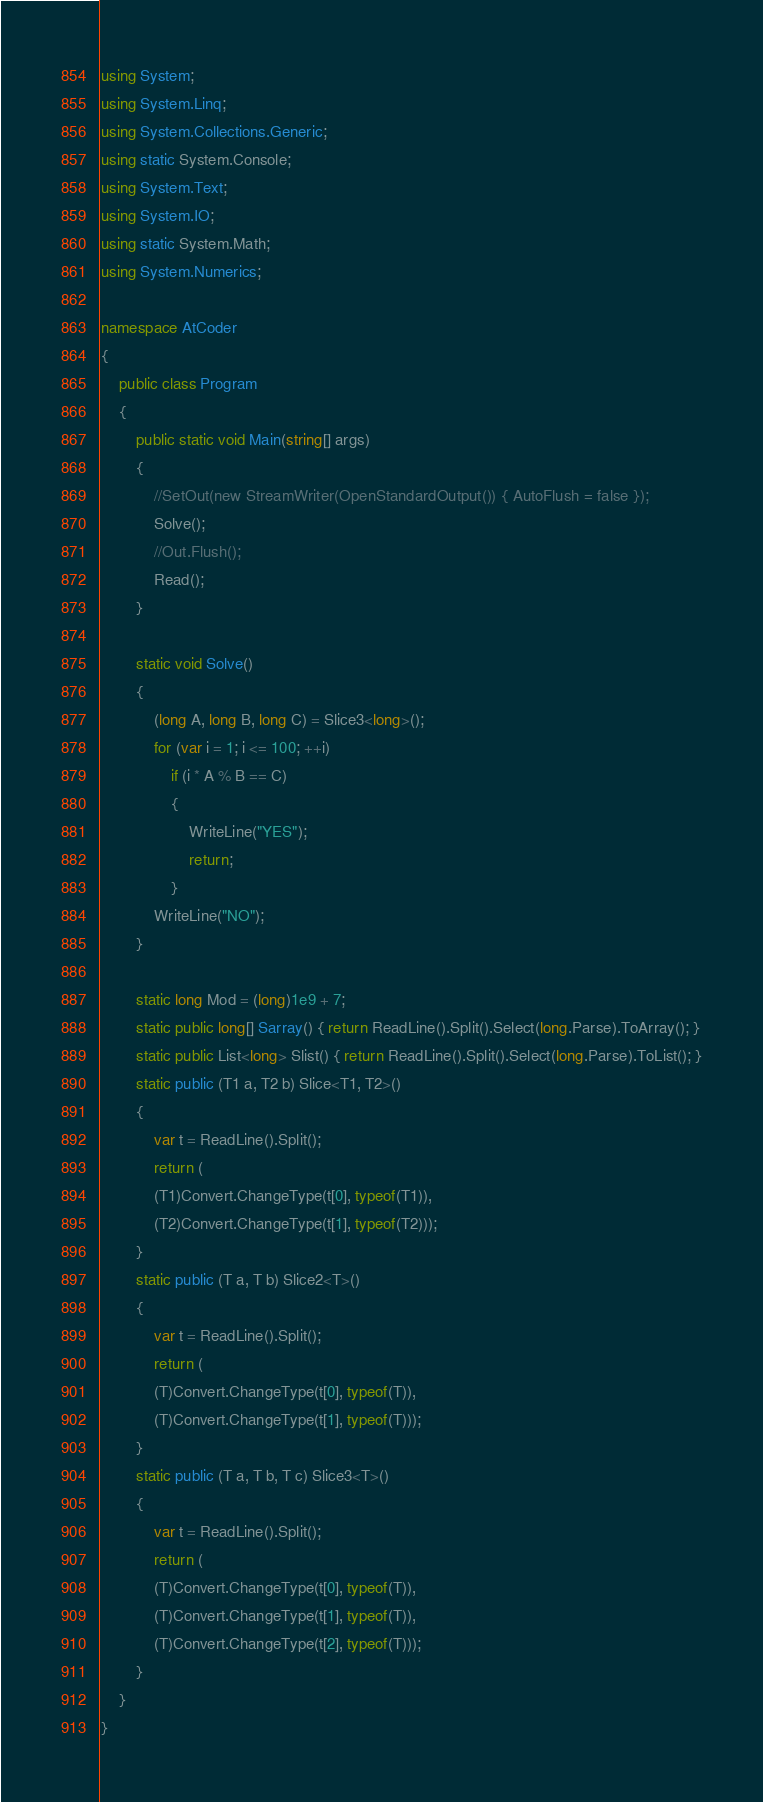<code> <loc_0><loc_0><loc_500><loc_500><_C#_>using System;
using System.Linq;
using System.Collections.Generic;
using static System.Console;
using System.Text;
using System.IO;
using static System.Math;
using System.Numerics;

namespace AtCoder
{
    public class Program
    {
        public static void Main(string[] args)
        {
            //SetOut(new StreamWriter(OpenStandardOutput()) { AutoFlush = false });
            Solve();
            //Out.Flush();
            Read();
        }

        static void Solve()
        {
            (long A, long B, long C) = Slice3<long>();
            for (var i = 1; i <= 100; ++i)
                if (i * A % B == C)
                {
                    WriteLine("YES");
                    return;
                }
            WriteLine("NO");
        }

        static long Mod = (long)1e9 + 7;
        static public long[] Sarray() { return ReadLine().Split().Select(long.Parse).ToArray(); }
        static public List<long> Slist() { return ReadLine().Split().Select(long.Parse).ToList(); }
        static public (T1 a, T2 b) Slice<T1, T2>()
        {
            var t = ReadLine().Split();
            return (
            (T1)Convert.ChangeType(t[0], typeof(T1)),
            (T2)Convert.ChangeType(t[1], typeof(T2)));
        }
        static public (T a, T b) Slice2<T>()
        {
            var t = ReadLine().Split();
            return (
            (T)Convert.ChangeType(t[0], typeof(T)),
            (T)Convert.ChangeType(t[1], typeof(T)));
        }
        static public (T a, T b, T c) Slice3<T>()
        {
            var t = ReadLine().Split();
            return (
            (T)Convert.ChangeType(t[0], typeof(T)),
            (T)Convert.ChangeType(t[1], typeof(T)),
            (T)Convert.ChangeType(t[2], typeof(T)));
        }
    }
}</code> 